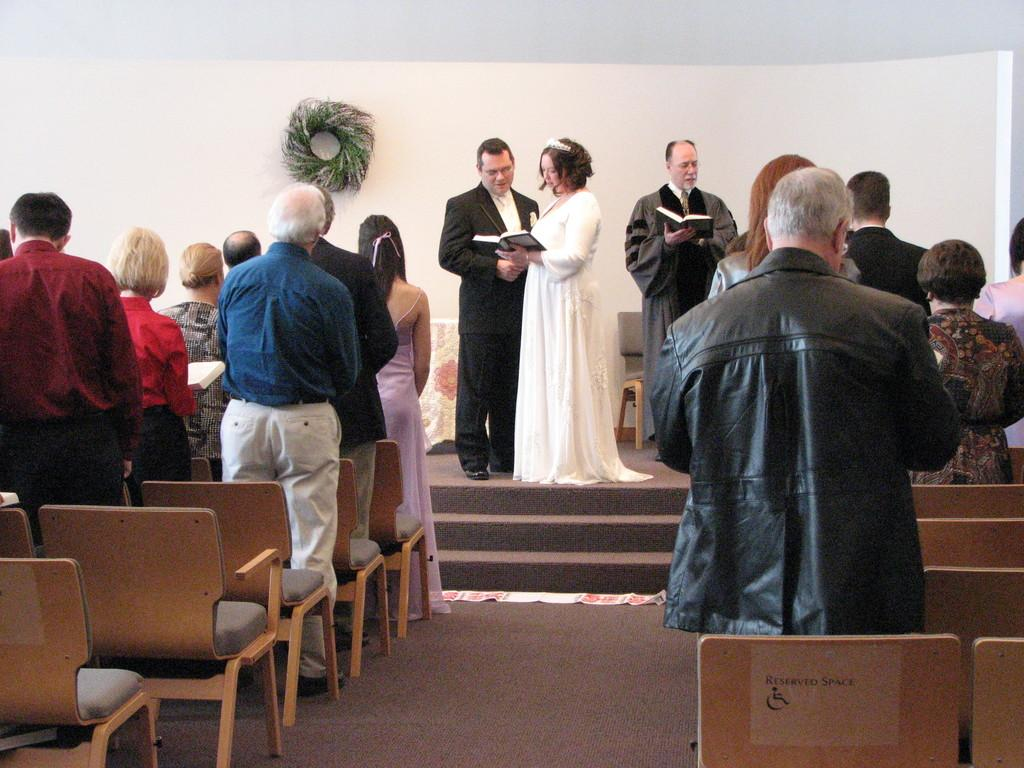How many people are in the image? There are people in the image, but the exact number is not specified. What are the people in the image doing? All the people in the image are standing. What type of gold object is being used by the people in the image? There is no gold object present in the image. What color is the celery that the people are holding in the image? There is no celery present in the image. 